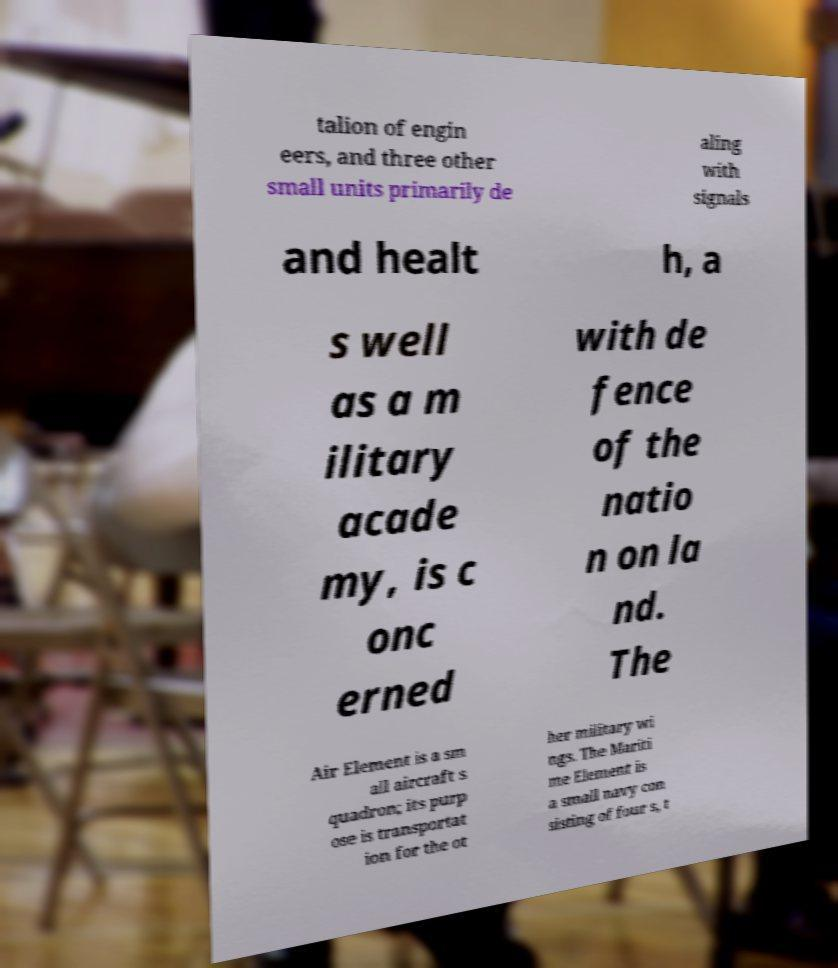Could you assist in decoding the text presented in this image and type it out clearly? talion of engin eers, and three other small units primarily de aling with signals and healt h, a s well as a m ilitary acade my, is c onc erned with de fence of the natio n on la nd. The Air Element is a sm all aircraft s quadron; its purp ose is transportat ion for the ot her military wi ngs. The Mariti me Element is a small navy con sisting of four s, t 